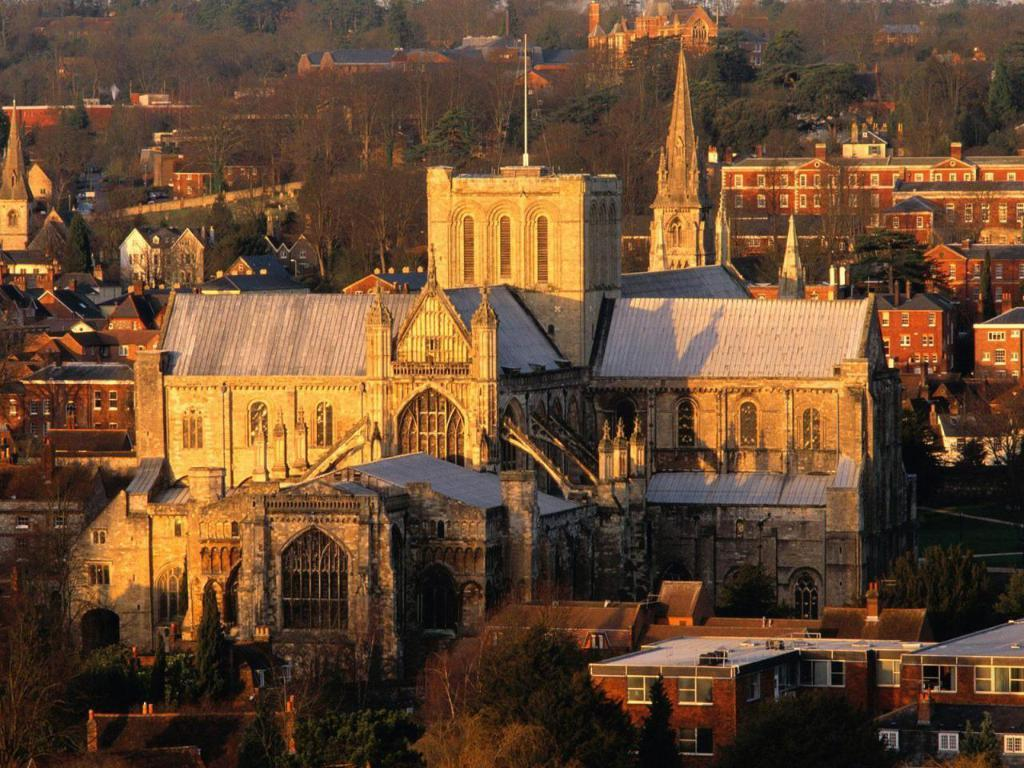What type of structures are in the center of the image? There are historic buildings in the center of the image. What can be seen at the bottom of the image? There are trees at the bottom of the image. What is present at the top of the image? There are trees at the top of the image. What type of coat is hanging on the tree at the top of the image? There is no coat present in the image; it only features historic buildings and trees. 